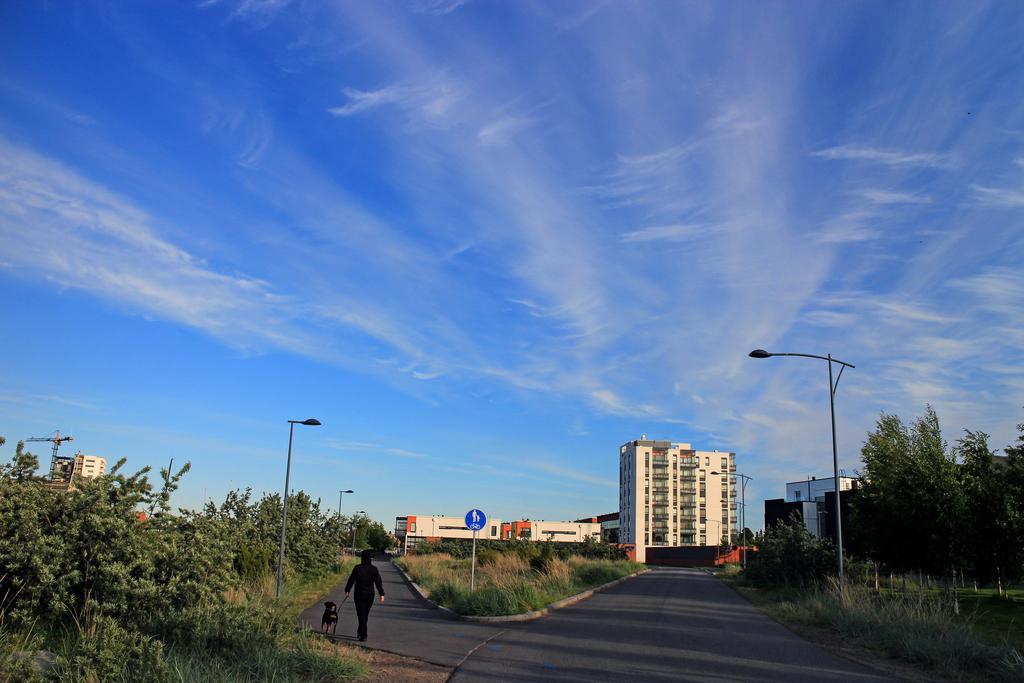Please provide a concise description of this image. In this picture we can see a person in the middle of the image, beside to the person we can find a dog, poles and few trees, in the background we can find few buildings, sign boards crane and clouds. 